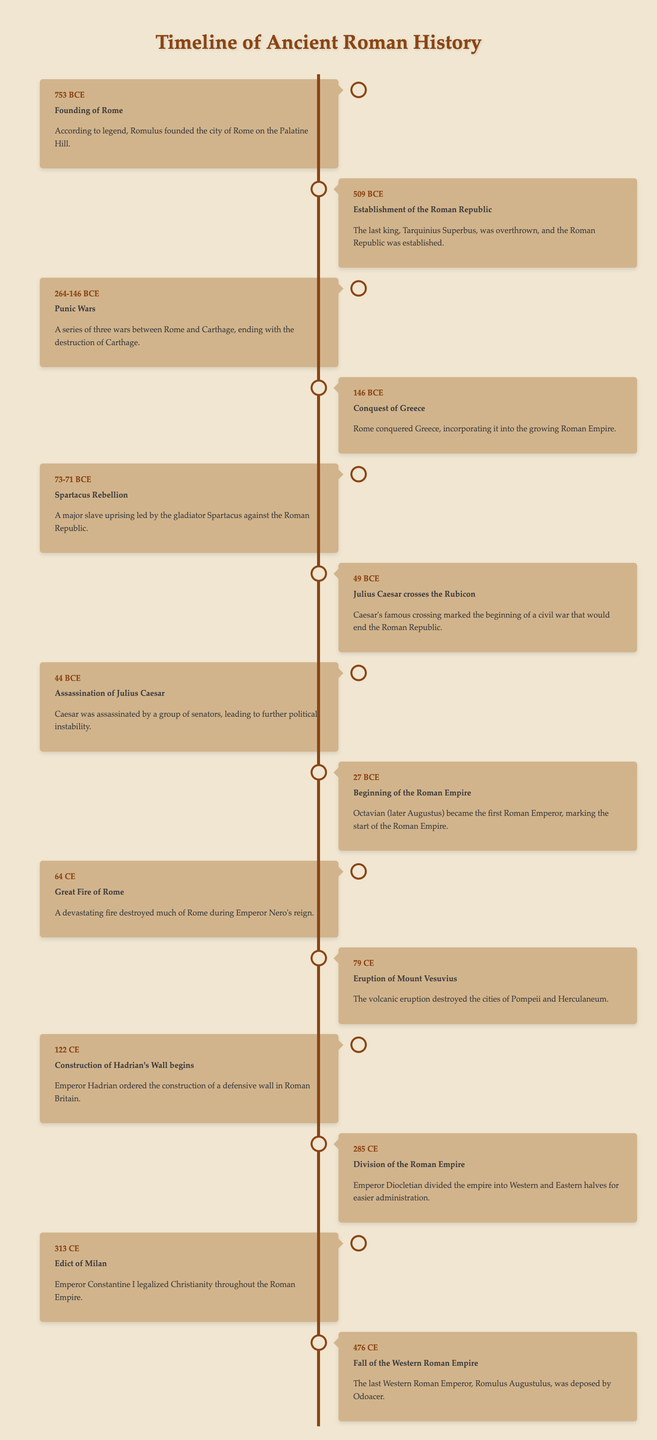What year marks the founding of Rome? The table directly states that the founding of Rome occurred in 753 BCE.
Answer: 753 BCE How many years did the Punic Wars span? The Punic Wars took place from 264 BCE to 146 BCE. To find the span, we subtract 146 from 264, which equals 118 years.
Answer: 118 years Was Julius Caesar assassinated before or after the establishment of the Roman Empire? The establishment of the Roman Empire occurred in 27 BCE, while Julius Caesar was assassinated in 44 BCE, which is before the establishment.
Answer: Before What event occurred in 64 CE? The table indicates that in 64 CE, the Great Fire of Rome occurred, destroying much of the city.
Answer: Great Fire of Rome What is the time gap between the conquest of Greece and the fall of the Western Roman Empire? The conquest of Greece happened in 146 BCE and the fall of the Western Roman Empire occurred in 476 CE. To calculate the time gap, we first convert 146 BCE to a positive number for calculation: 146 + 476 equals 622 years.
Answer: 622 years How many major events are listed in the timeline? Counting each entry in the timeline, there are 15 major events listed.
Answer: 15 Did Emperor Constantine I issue the Edict of Milan? Yes, the table confirms that in 313 CE, Emperor Constantine I legalized Christianity throughout the Roman Empire through the Edict of Milan.
Answer: Yes What year did Hadrian's Wall construction begin? According to the timeline, the construction of Hadrian's Wall began in 122 CE.
Answer: 122 CE Which event led to further political instability after Caesar's assassination? The table states that after Caesar's assassination in 44 BCE, further political instability ensued, highlighting that this event was critical in Roman politics.
Answer: Further political instability What was the last event listed in the timeline? The last event mentioned in the timeline is the Fall of the Western Roman Empire, which occurred in 476 CE.
Answer: Fall of the Western Roman Empire 